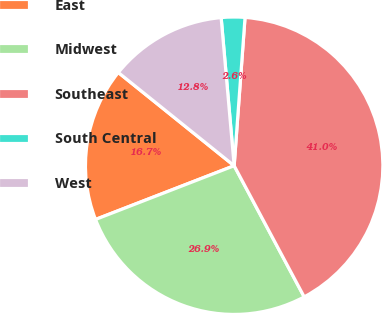<chart> <loc_0><loc_0><loc_500><loc_500><pie_chart><fcel>East<fcel>Midwest<fcel>Southeast<fcel>South Central<fcel>West<nl><fcel>16.67%<fcel>26.92%<fcel>41.03%<fcel>2.56%<fcel>12.82%<nl></chart> 